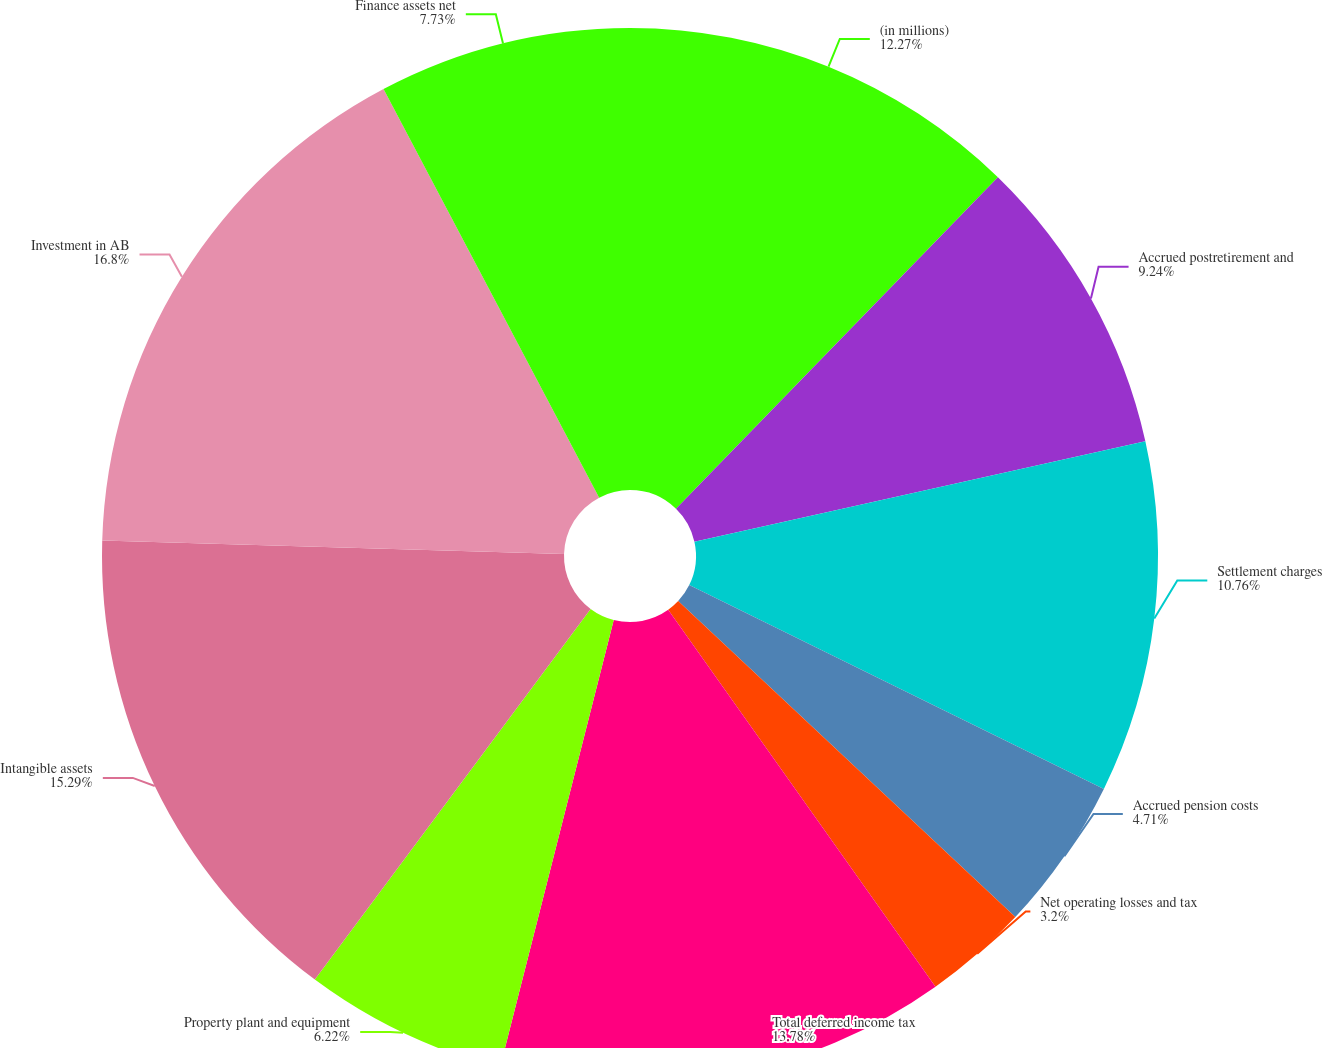<chart> <loc_0><loc_0><loc_500><loc_500><pie_chart><fcel>(in millions)<fcel>Accrued postretirement and<fcel>Settlement charges<fcel>Accrued pension costs<fcel>Net operating losses and tax<fcel>Total deferred income tax<fcel>Property plant and equipment<fcel>Intangible assets<fcel>Investment in AB<fcel>Finance assets net<nl><fcel>12.27%<fcel>9.24%<fcel>10.76%<fcel>4.71%<fcel>3.2%<fcel>13.78%<fcel>6.22%<fcel>15.29%<fcel>16.8%<fcel>7.73%<nl></chart> 